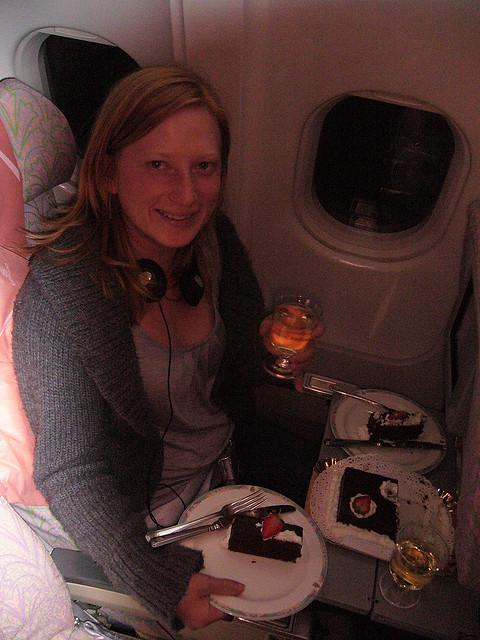Where is this woman feasting? airplane 